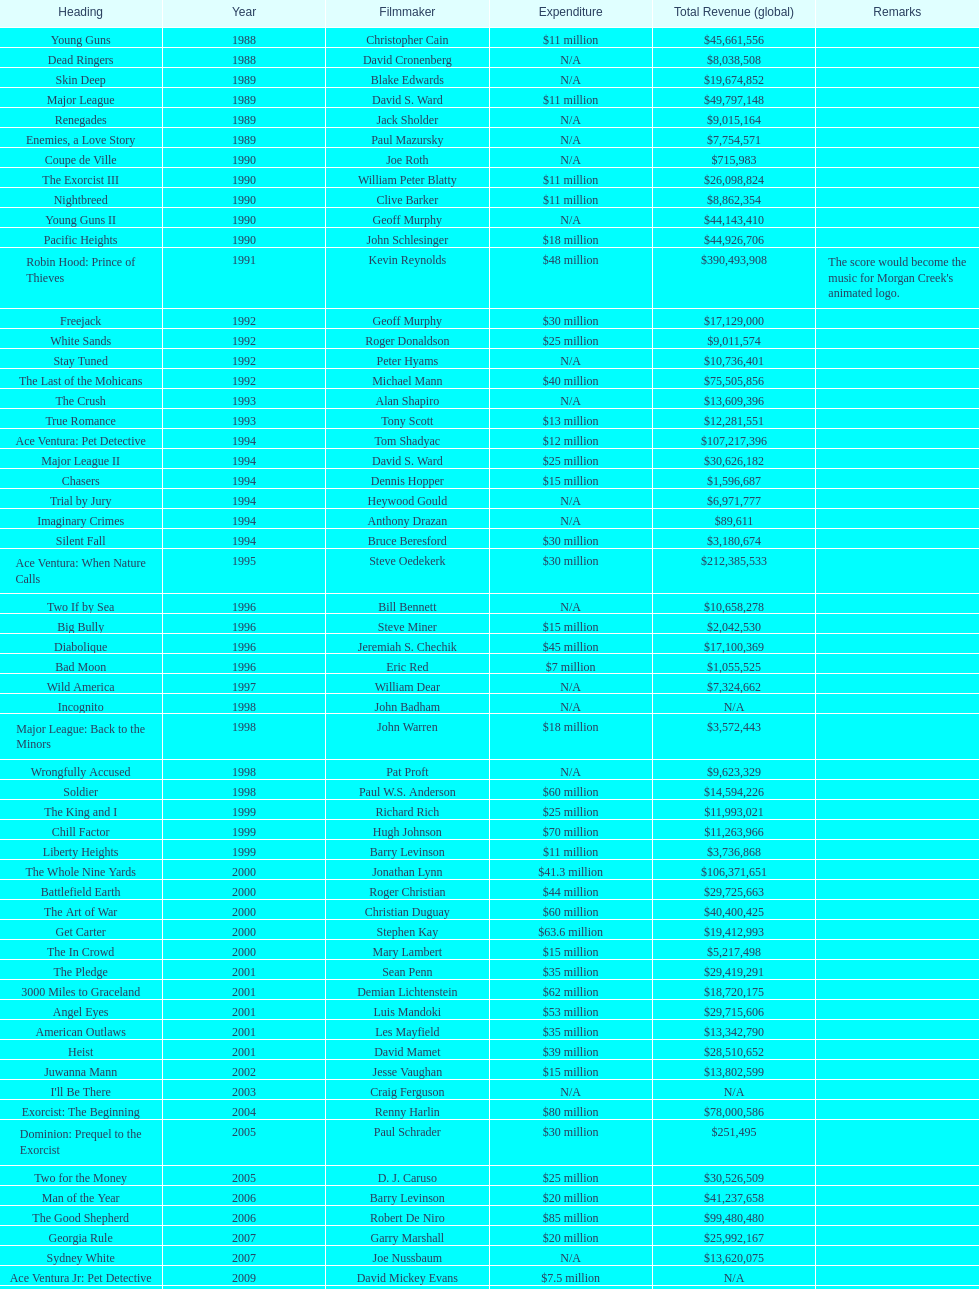After young guns, what was the next movie with the exact same budget? Major League. 